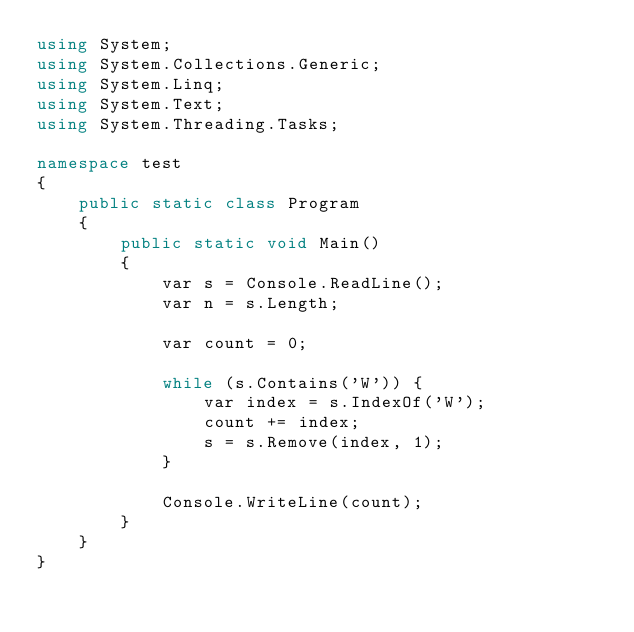Convert code to text. <code><loc_0><loc_0><loc_500><loc_500><_C#_>using System;
using System.Collections.Generic;
using System.Linq;
using System.Text;
using System.Threading.Tasks;

namespace test
{
	public static class Program
	{
		public static void Main()
		{
			var s = Console.ReadLine();
			var n = s.Length;

			var count = 0;

			while (s.Contains('W')) {
				var index = s.IndexOf('W');
				count += index;
				s = s.Remove(index, 1);
			}

			Console.WriteLine(count);
		}
	}
}
</code> 